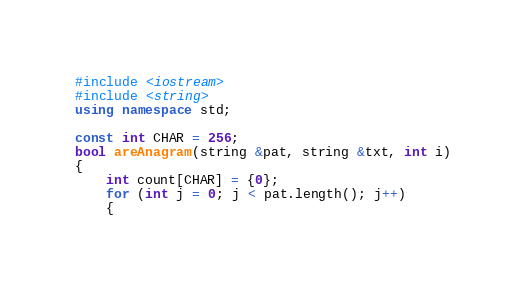Convert code to text. <code><loc_0><loc_0><loc_500><loc_500><_C++_>#include <iostream>
#include <string>
using namespace std;

const int CHAR = 256;
bool areAnagram(string &pat, string &txt, int i)
{
    int count[CHAR] = {0};
    for (int j = 0; j < pat.length(); j++)
    {</code> 